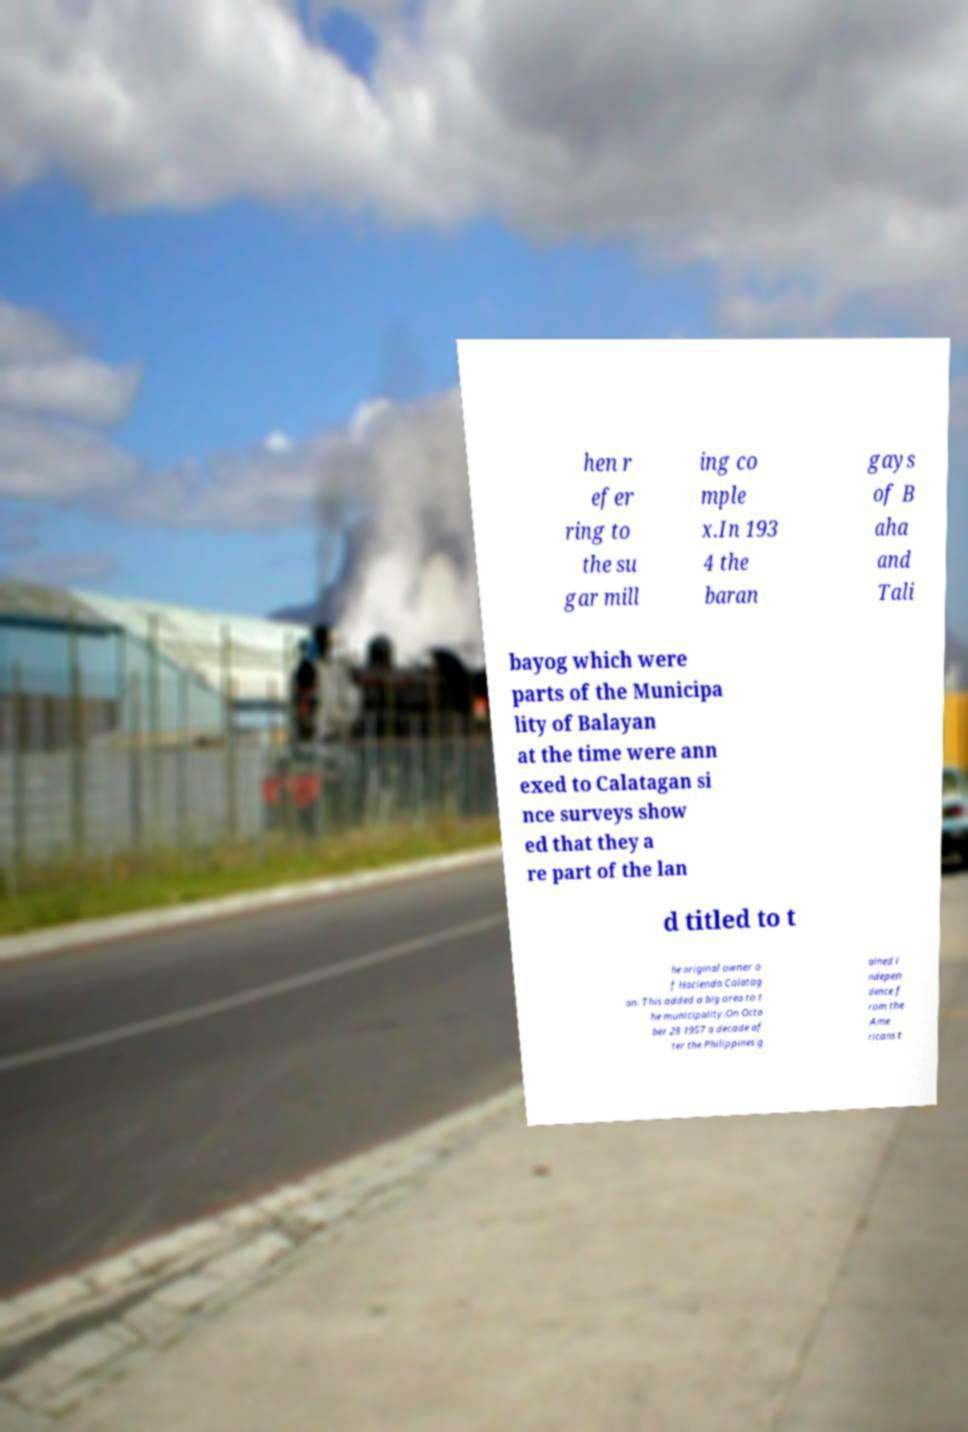I need the written content from this picture converted into text. Can you do that? hen r efer ring to the su gar mill ing co mple x.In 193 4 the baran gays of B aha and Tali bayog which were parts of the Municipa lity of Balayan at the time were ann exed to Calatagan si nce surveys show ed that they a re part of the lan d titled to t he original owner o f Hacienda Calatag an. This added a big area to t he municipality.On Octo ber 28 1957 a decade af ter the Philippines g ained i ndepen dence f rom the Ame ricans t 